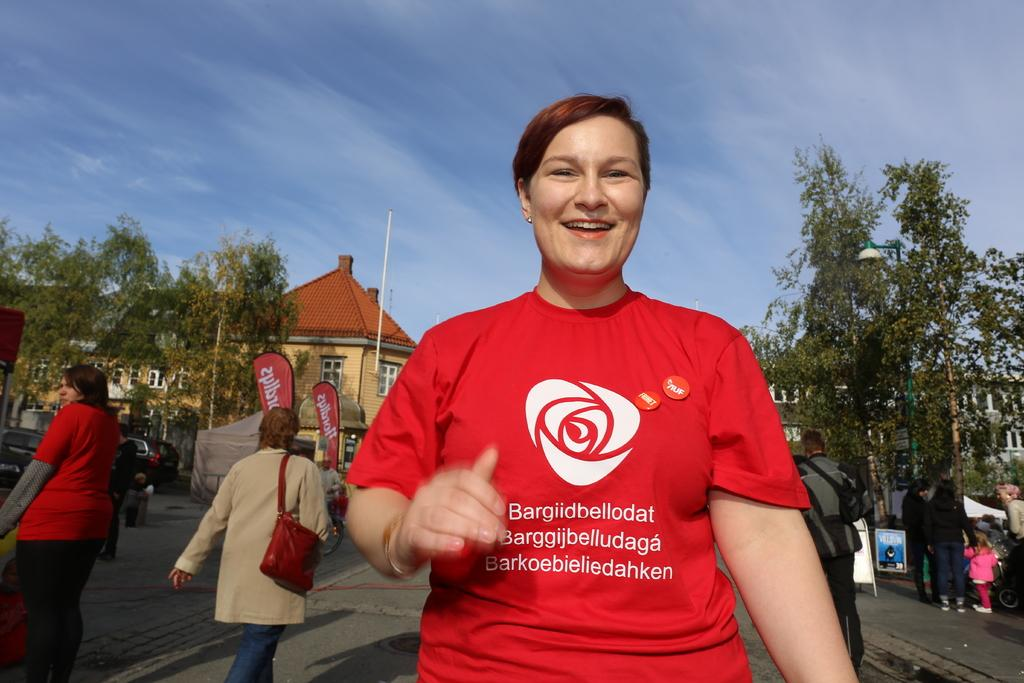What can be seen in the image? There are people, tents, boards, vehicles, trees, light, buildings, poles, and banners visible in the image. Can you describe the setting of the image? The image appears to be outdoors, with trees, tents, and vehicles present. There are also buildings and poles visible, suggesting an urban or semi-urban setting. What is the weather like in the image? The sky is cloudy in the image, indicating that it might be overcast or cloudy. What type of bushes can be seen growing near the buildings in the image? There are no bushes visible in the image; only trees, tents, vehicles, and other objects are present. 